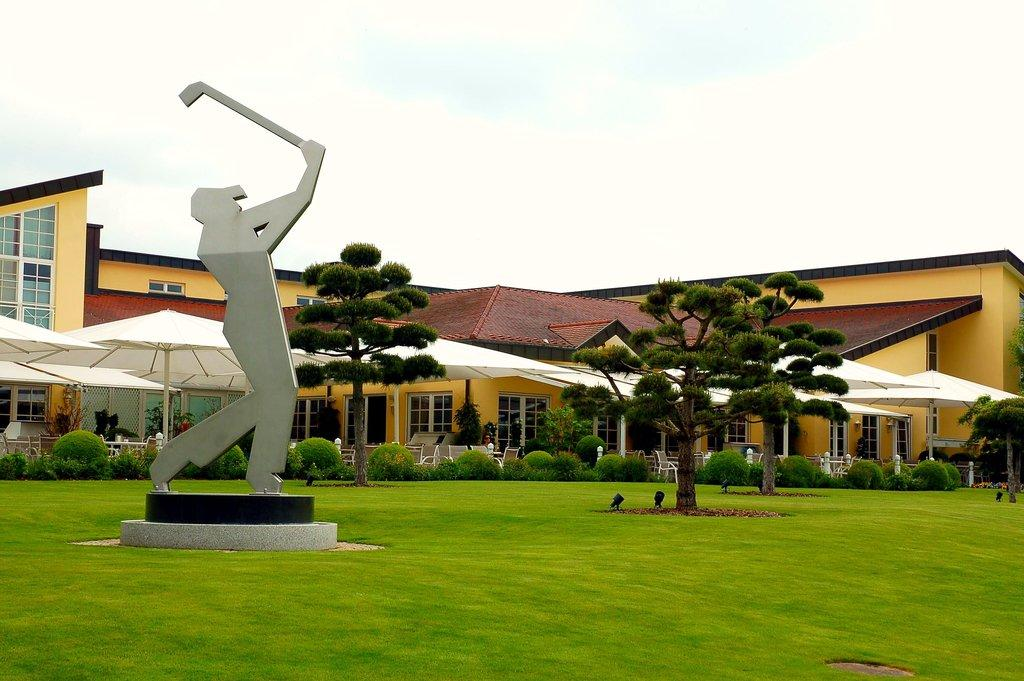What type of content is present in the image? The image contains stories. What objects can be seen in the image related to weather protection? There are umbrellas in the image. What type of structure is visible in the image? There is a building in the image. What type of artwork is present in the image? There is a statue in the image. What type of ground surface is visible in the image? Grass is present on the ground in the image. What is the condition of the sky in the image? The sky is cloudy in the image. What type of blade is being used to create humor in the image? There is no blade or humor present in the image; it contains stories, umbrellas, a building, a statue, grass, and a cloudy sky. 